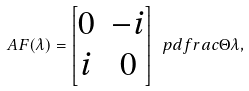<formula> <loc_0><loc_0><loc_500><loc_500>\ A F ( \lambda ) = \begin{bmatrix} 0 & - i \\ i & 0 \end{bmatrix} \ p d f r a c { \Theta } { \lambda } ,</formula> 